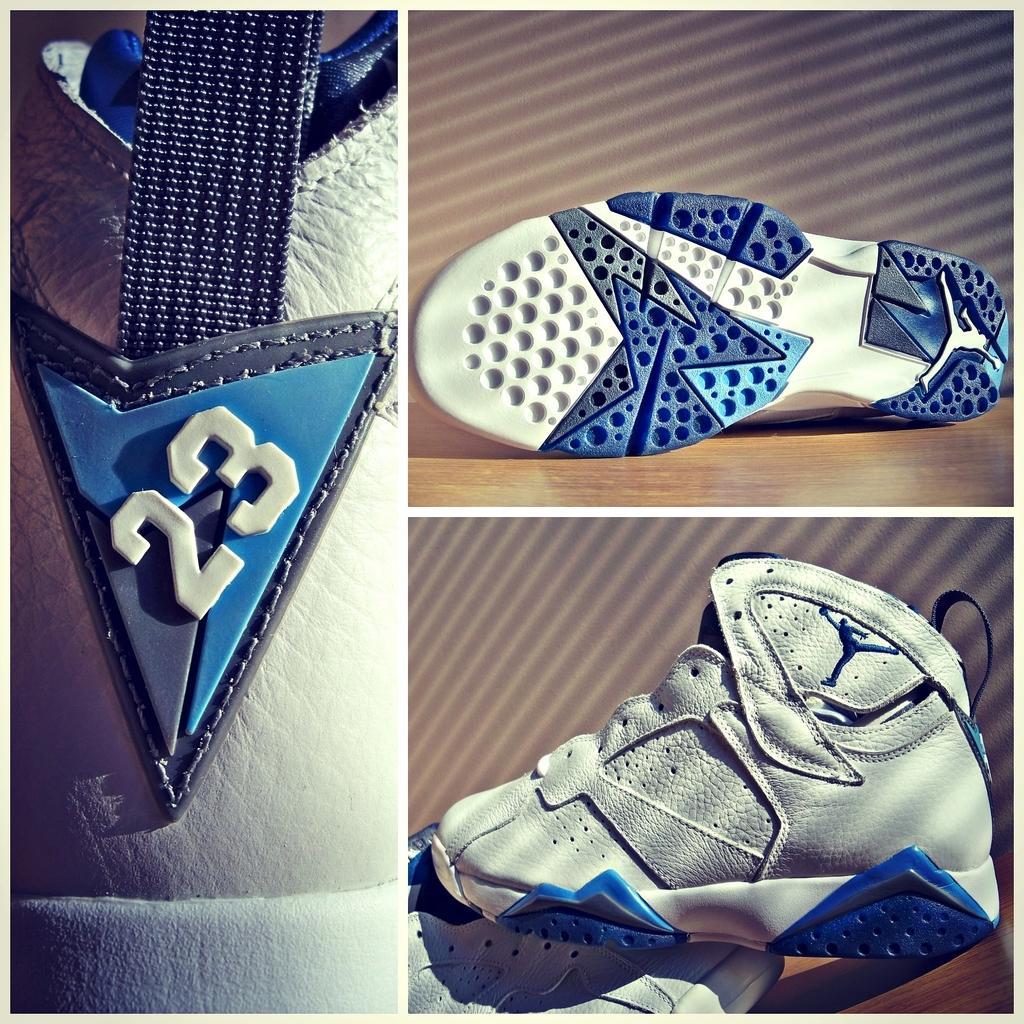Could you give a brief overview of what you see in this image? In this image I can see a collage picture in which I can see a footwear which is white, blue and black in color. 